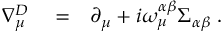Convert formula to latex. <formula><loc_0><loc_0><loc_500><loc_500>\begin{array} { r l r } { \nabla _ { \mu } ^ { D } } & = } & { \partial _ { \mu } + i \omega _ { \mu } ^ { \alpha \beta } \Sigma _ { \alpha \beta } \, . } \end{array}</formula> 